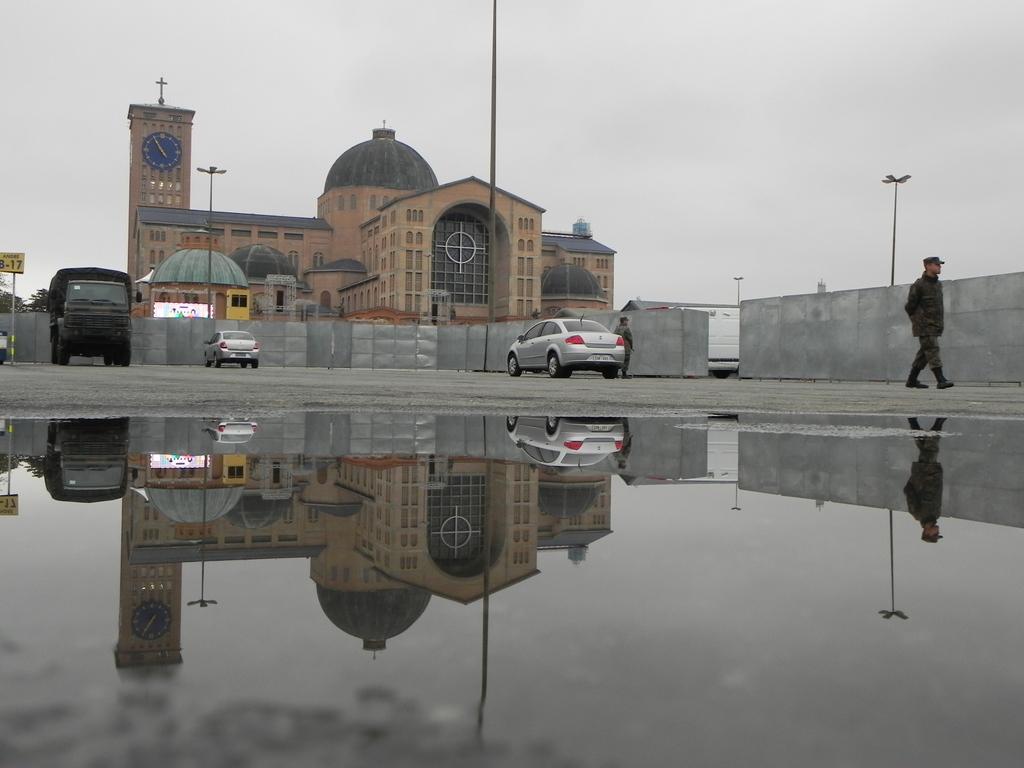Could you give a brief overview of what you see in this image? In this picture I can see there are vehicles parked here and there are two persons standing and in the backdrop I can see there is a building and the sky is clear. 